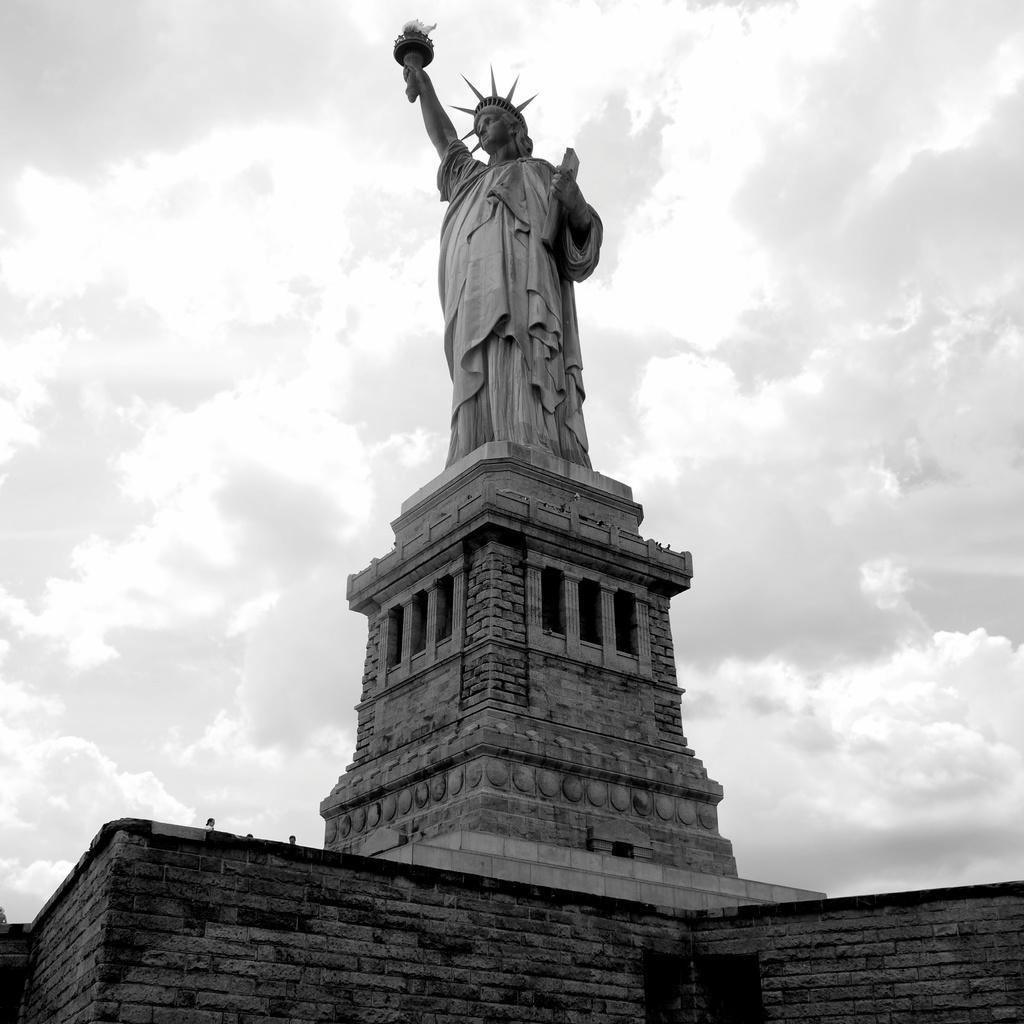In one or two sentences, can you explain what this image depicts? In this image in the center there is one statue and at the bottom there is a wall, on the top of the image there is sky. 